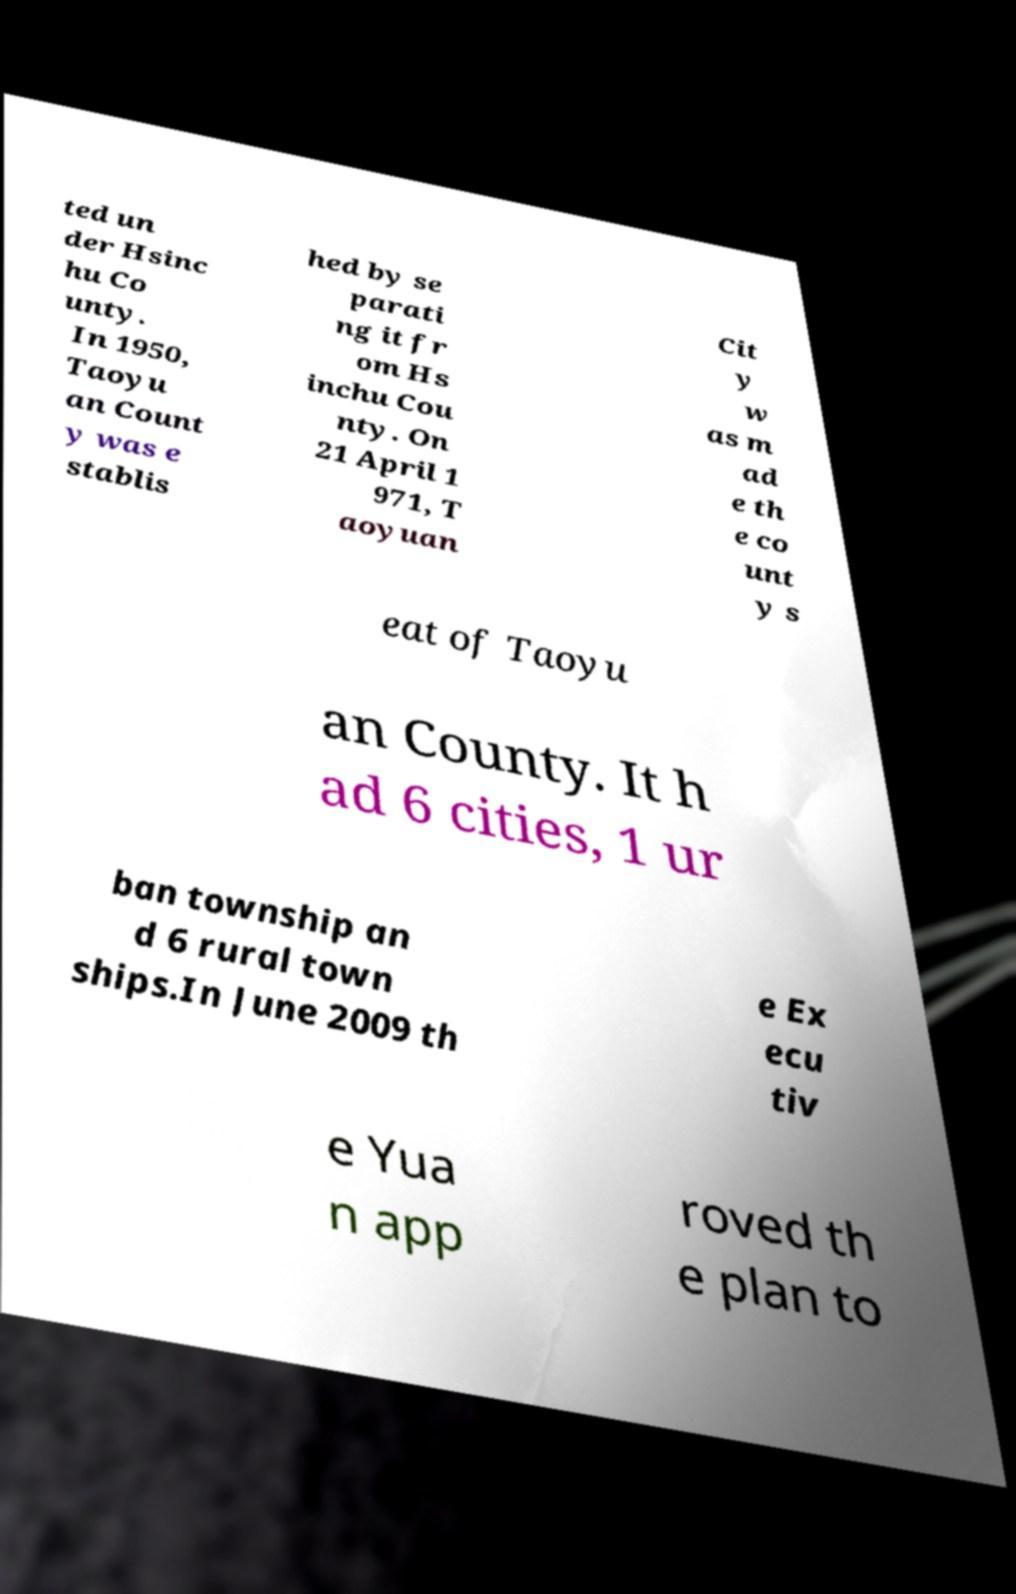Could you assist in decoding the text presented in this image and type it out clearly? ted un der Hsinc hu Co unty. In 1950, Taoyu an Count y was e stablis hed by se parati ng it fr om Hs inchu Cou nty. On 21 April 1 971, T aoyuan Cit y w as m ad e th e co unt y s eat of Taoyu an County. It h ad 6 cities, 1 ur ban township an d 6 rural town ships.In June 2009 th e Ex ecu tiv e Yua n app roved th e plan to 